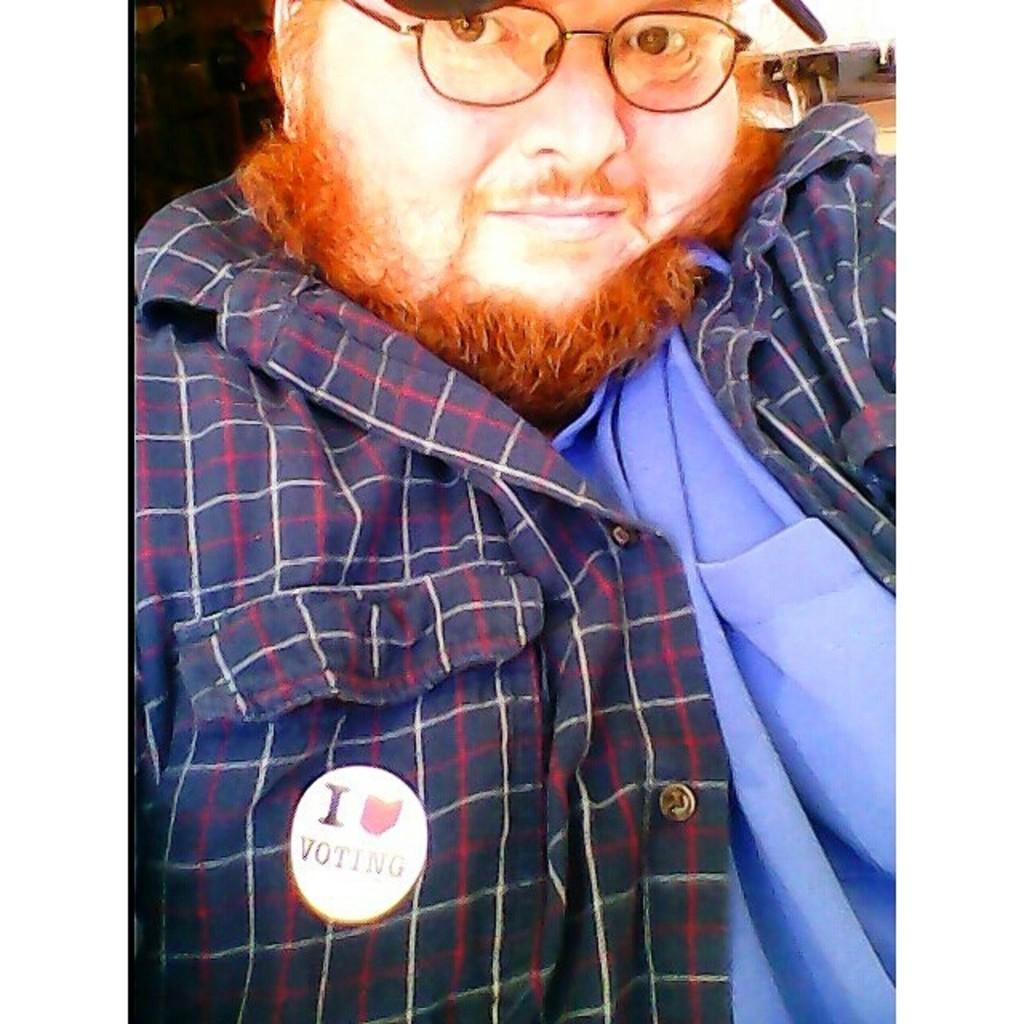What is the main subject of the image? The main subject of the image is a man. What is the man wearing on his upper body? The man is wearing a shirt. Are there any accessories visible on the man? Yes, the man is wearing specs and a cap. What can be seen on the man's shirt? There is written on the man's shirt. How many crows are sitting on the van in the image? There is no van or crow present in the image. What type of street can be seen in the background of the image? There is no street visible in the image; it only features a man wearing a shirt, specs, and a cap. 